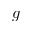<formula> <loc_0><loc_0><loc_500><loc_500>g</formula> 